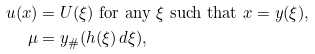<formula> <loc_0><loc_0><loc_500><loc_500>u ( x ) & = U ( \xi ) \text { for any } \xi \text { such that } x = y ( \xi ) , \\ \mu & = y _ { \# } ( h ( \xi ) \, d \xi ) ,</formula> 